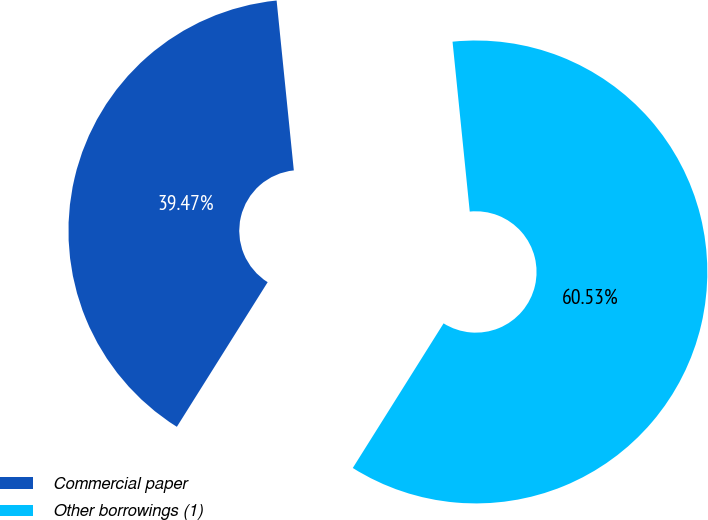Convert chart. <chart><loc_0><loc_0><loc_500><loc_500><pie_chart><fcel>Commercial paper<fcel>Other borrowings (1)<nl><fcel>39.47%<fcel>60.53%<nl></chart> 